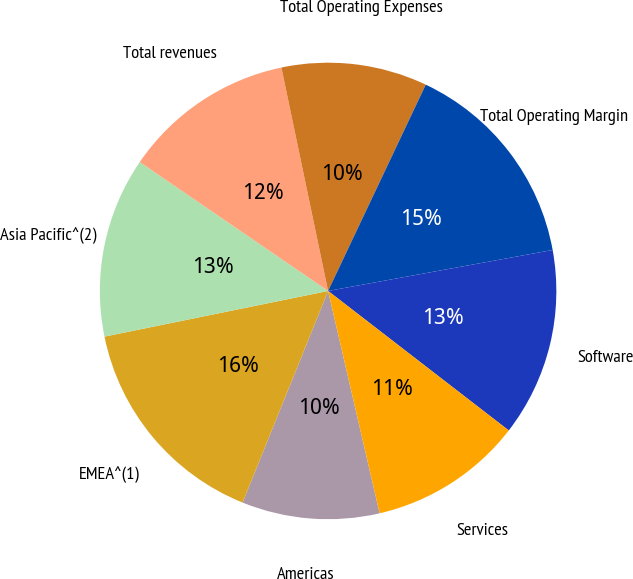Convert chart. <chart><loc_0><loc_0><loc_500><loc_500><pie_chart><fcel>Americas<fcel>EMEA^(1)<fcel>Asia Pacific^(2)<fcel>Total revenues<fcel>Total Operating Expenses<fcel>Total Operating Margin<fcel>Software<fcel>Services<nl><fcel>9.74%<fcel>15.68%<fcel>12.76%<fcel>12.17%<fcel>10.32%<fcel>15.09%<fcel>13.34%<fcel>10.91%<nl></chart> 